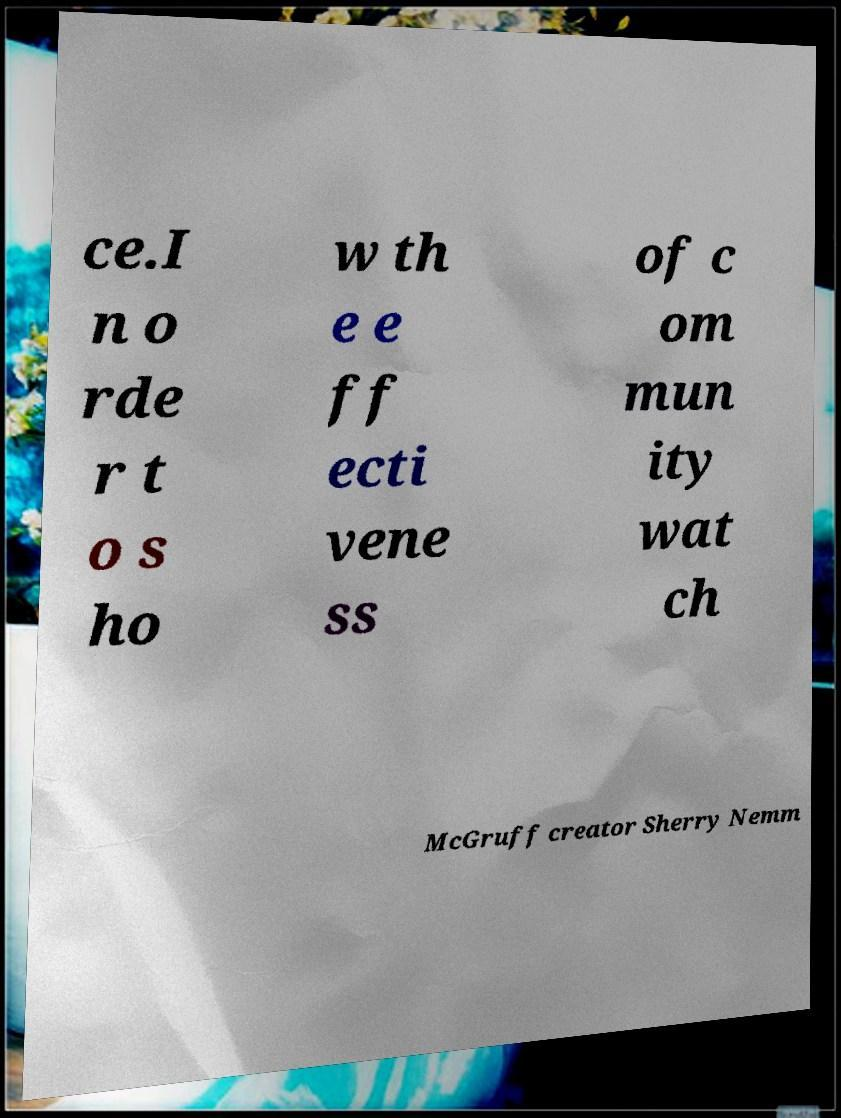What messages or text are displayed in this image? I need them in a readable, typed format. ce.I n o rde r t o s ho w th e e ff ecti vene ss of c om mun ity wat ch McGruff creator Sherry Nemm 